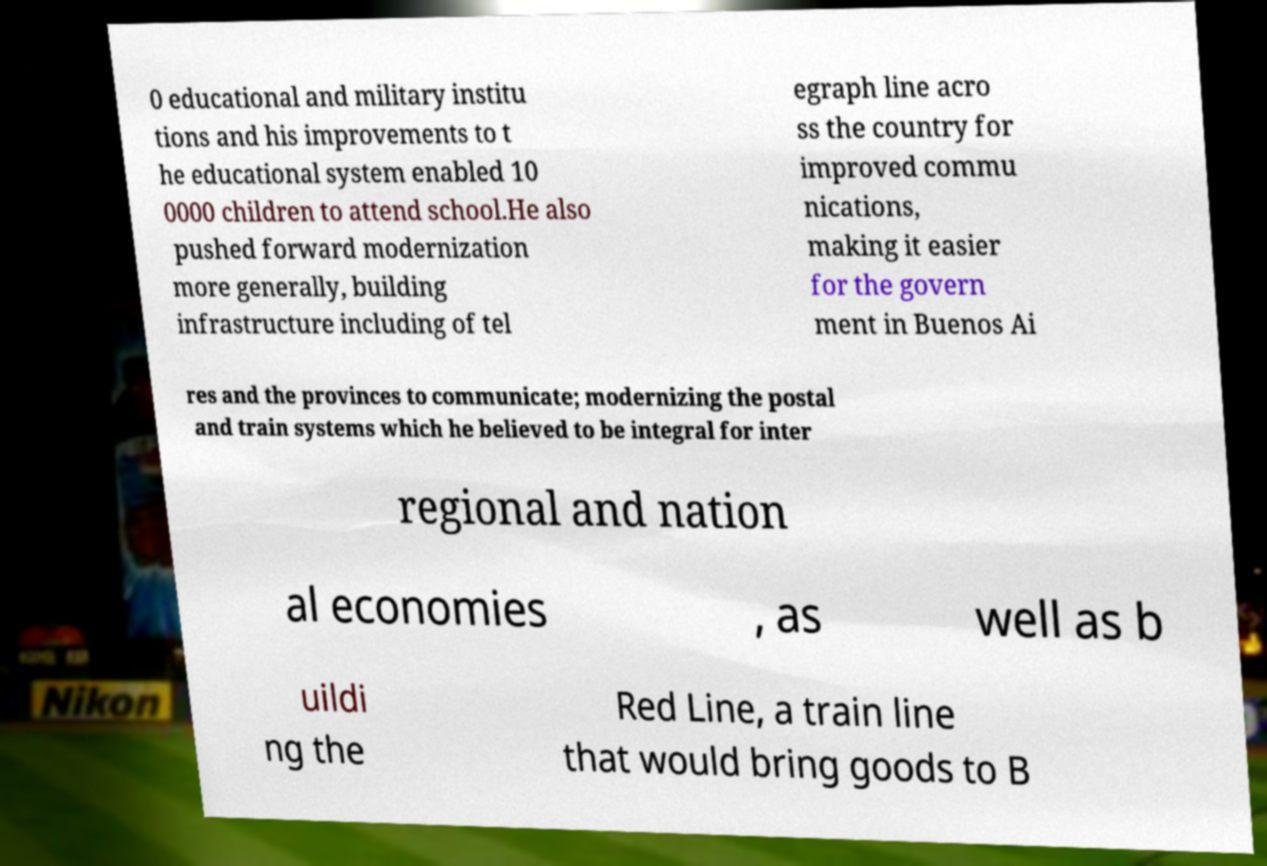There's text embedded in this image that I need extracted. Can you transcribe it verbatim? 0 educational and military institu tions and his improvements to t he educational system enabled 10 0000 children to attend school.He also pushed forward modernization more generally, building infrastructure including of tel egraph line acro ss the country for improved commu nications, making it easier for the govern ment in Buenos Ai res and the provinces to communicate; modernizing the postal and train systems which he believed to be integral for inter regional and nation al economies , as well as b uildi ng the Red Line, a train line that would bring goods to B 